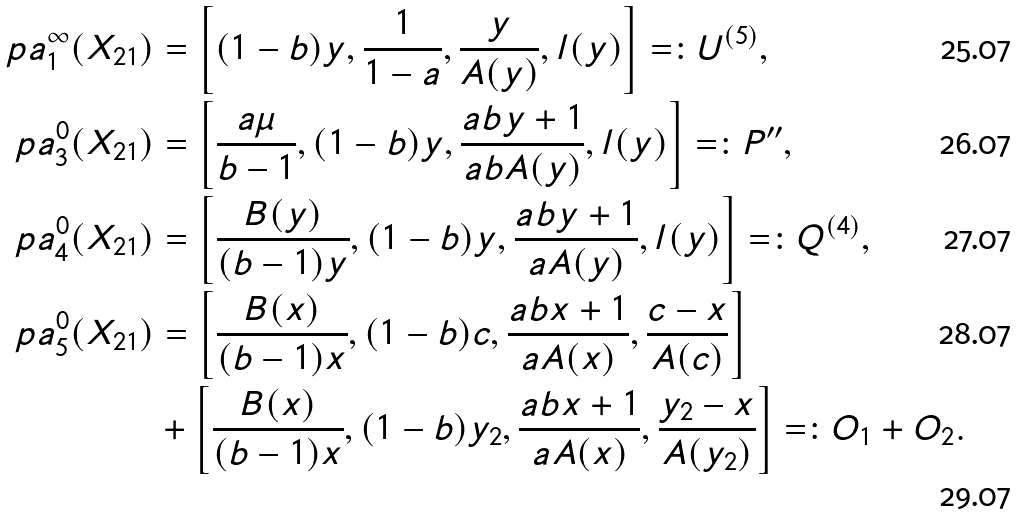<formula> <loc_0><loc_0><loc_500><loc_500>\ p a _ { 1 } ^ { \infty } ( X _ { 2 1 } ) & = \left [ ( 1 - b ) y , \frac { 1 } { 1 - a } , \frac { y } { A ( y ) } , l ( y ) \right ] = \colon U ^ { ( 5 ) } , \\ \ p a _ { 3 } ^ { 0 } ( X _ { 2 1 } ) & = \left [ \frac { a \mu } { b - 1 } , ( 1 - b ) y , \frac { a b y + 1 } { a b A ( y ) } , l ( y ) \right ] = \colon P ^ { \prime \prime } , \\ \ p a _ { 4 } ^ { 0 } ( X _ { 2 1 } ) & = \left [ \frac { B ( y ) } { ( b - 1 ) y } , ( 1 - b ) y , \frac { a b y + 1 } { a A ( y ) } , l ( y ) \right ] = \colon Q ^ { ( 4 ) } , \\ \ p a _ { 5 } ^ { 0 } ( X _ { 2 1 } ) & = \left [ \frac { B ( x ) } { ( b - 1 ) x } , ( 1 - b ) c , \frac { a b x + 1 } { a A ( x ) } , \frac { c - x } { A ( c ) } \right ] \\ \ & + \left [ \frac { B ( x ) } { ( b - 1 ) x } , ( 1 - b ) y _ { 2 } , \frac { a b x + 1 } { a A ( x ) } , \frac { y _ { 2 } - x } { A ( y _ { 2 } ) } \right ] = \colon O _ { 1 } + O _ { 2 } .</formula> 